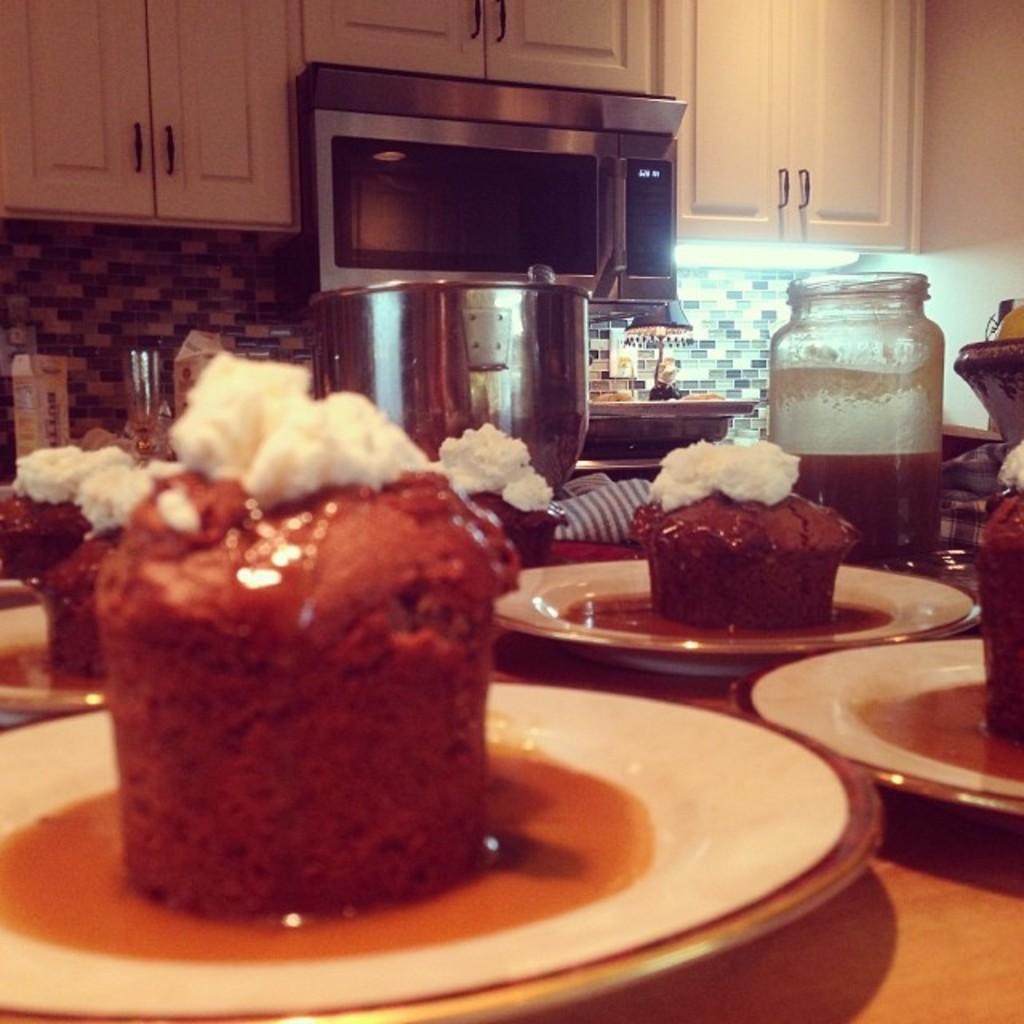Can you describe this image briefly? In this picture we can see food in the plates, beside the plate we can see a jar and a bowl, in the background we can find a microwave oven, light and few packets. 